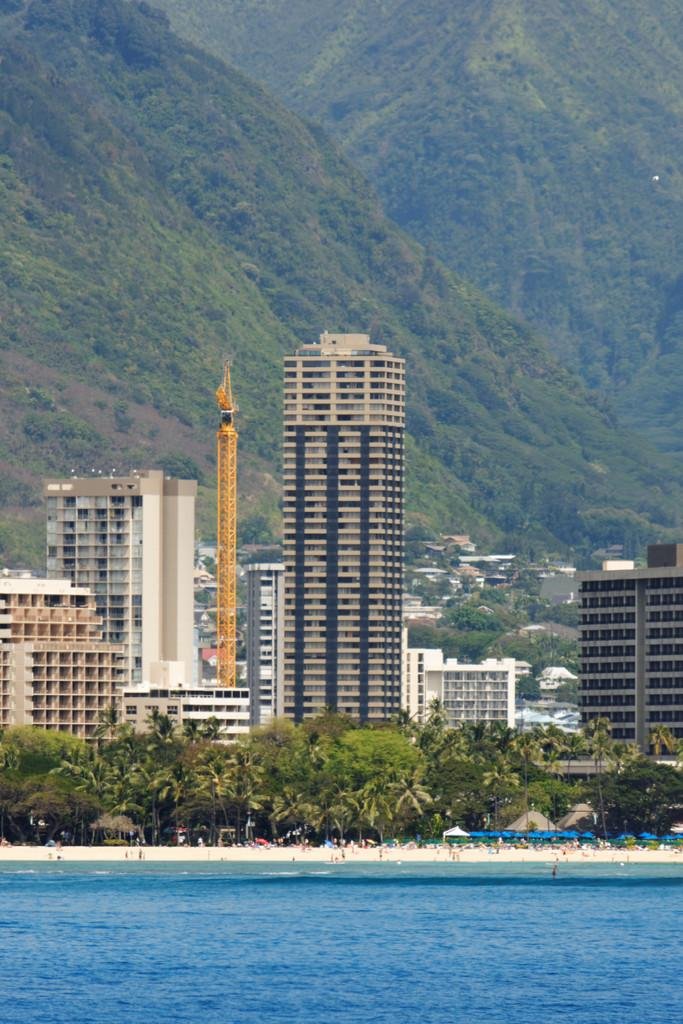What is located at the front of the image? There is water in the front of the image. What can be seen in the background of the image? There are trees, buildings, and mountains in the background of the image. How many geese are swimming in the water in the image? There are no geese present in the image; it features water in the front and trees, buildings, and mountains in the background. What type of mine is located near the mountains in the image? There is no mine present in the image; it features water in the front and trees, buildings, and mountains in the background. 